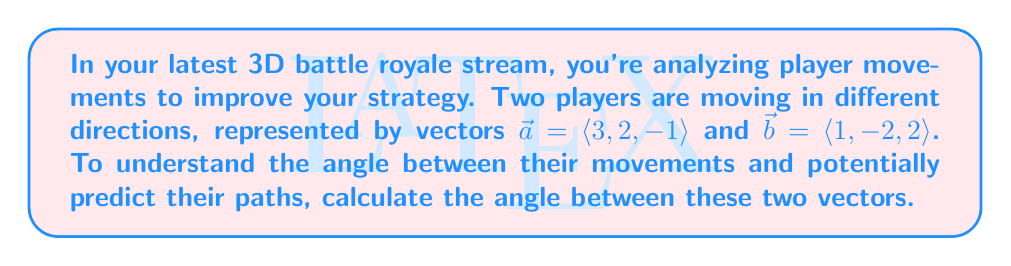Can you answer this question? To find the angle between two vectors, we can use the dot product formula:

$$\cos \theta = \frac{\vec{a} \cdot \vec{b}}{|\vec{a}| |\vec{b}|}$$

Where $\theta$ is the angle between the vectors, $\vec{a} \cdot \vec{b}$ is the dot product, and $|\vec{a}|$ and $|\vec{b}|$ are the magnitudes of the vectors.

Step 1: Calculate the dot product $\vec{a} \cdot \vec{b}$
$$\vec{a} \cdot \vec{b} = (3)(1) + (2)(-2) + (-1)(2) = 3 - 4 - 2 = -3$$

Step 2: Calculate the magnitudes of $\vec{a}$ and $\vec{b}$
$$|\vec{a}| = \sqrt{3^2 + 2^2 + (-1)^2} = \sqrt{14}$$
$$|\vec{b}| = \sqrt{1^2 + (-2)^2 + 2^2} = 3$$

Step 3: Substitute into the formula
$$\cos \theta = \frac{-3}{\sqrt{14} \cdot 3}$$

Step 4: Simplify
$$\cos \theta = -\frac{1}{\sqrt{14}}$$

Step 5: Take the inverse cosine (arccos) of both sides
$$\theta = \arccos\left(-\frac{1}{\sqrt{14}}\right)$$

Step 6: Calculate the final answer (rounded to two decimal places)
$$\theta \approx 1.82 \text{ radians} \approx 104.48°$$
Answer: The angle between the two vectors is approximately 1.82 radians or 104.48°. 